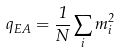<formula> <loc_0><loc_0><loc_500><loc_500>q _ { E A } = \frac { 1 } { N } \sum _ { i } m _ { i } ^ { 2 }</formula> 